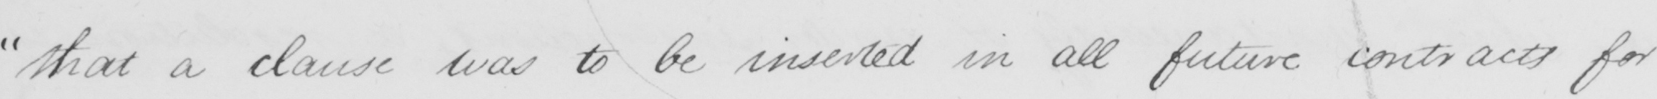Transcribe the text shown in this historical manuscript line. " that a clause was to be inserted in all future contracts for 